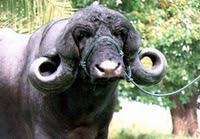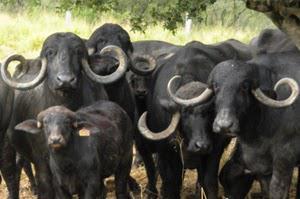The first image is the image on the left, the second image is the image on the right. Assess this claim about the two images: "The animals in the left image are next to a man made structure.". Correct or not? Answer yes or no. No. The first image is the image on the left, the second image is the image on the right. Analyze the images presented: Is the assertion "The foreground of each image contains water buffalo who look directly forward, and one image contains a single water buffalo in the foreground." valid? Answer yes or no. Yes. 